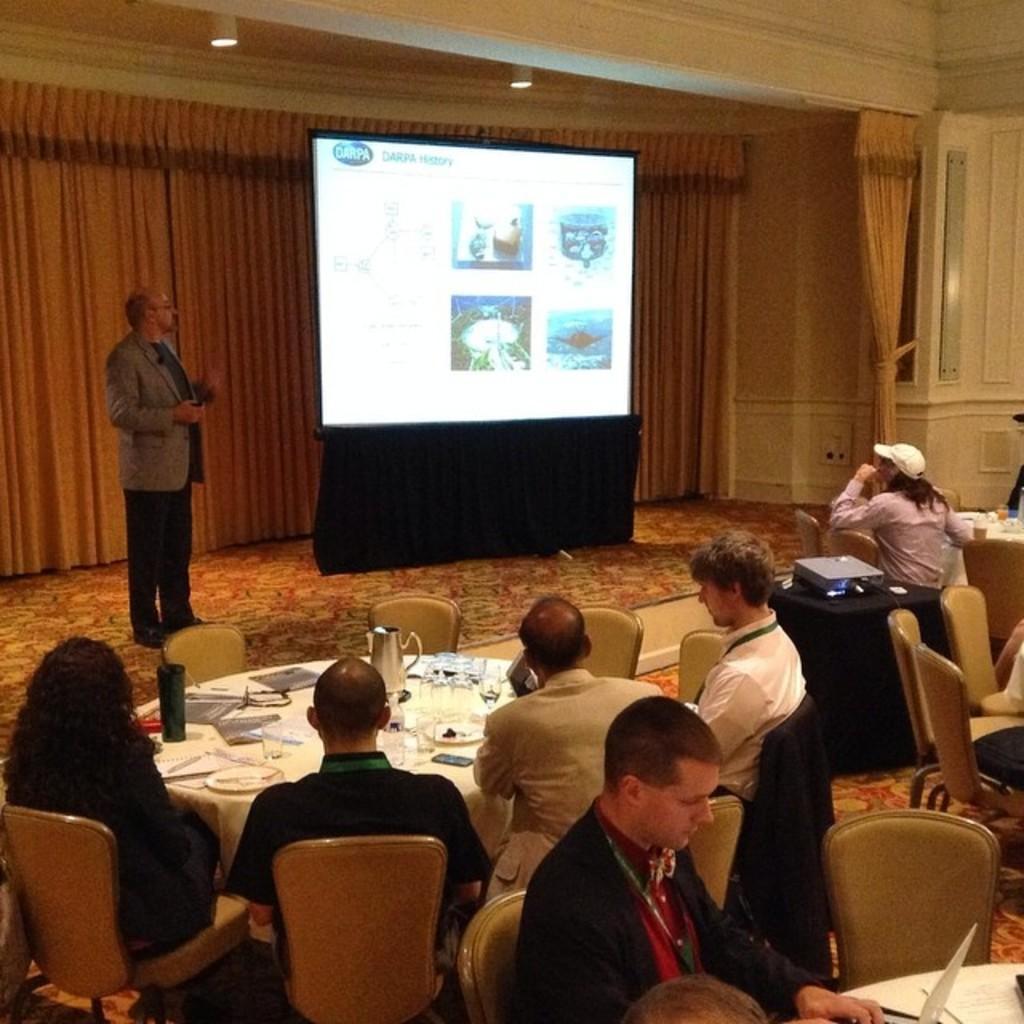Could you give a brief overview of what you see in this image? In the foreground of the picture I can see a few persons sitting on the chairs. There is a man at the bottom of the image and he is working on a laptop. I can see the tables and chairs on the floor. There are plates and glasses are kept on the table. There is a man standing on the carpet and he is looking at the screen. I can see the projector on the table on the right side. In the background, I can see the curtain and there are lamps on the roof. 